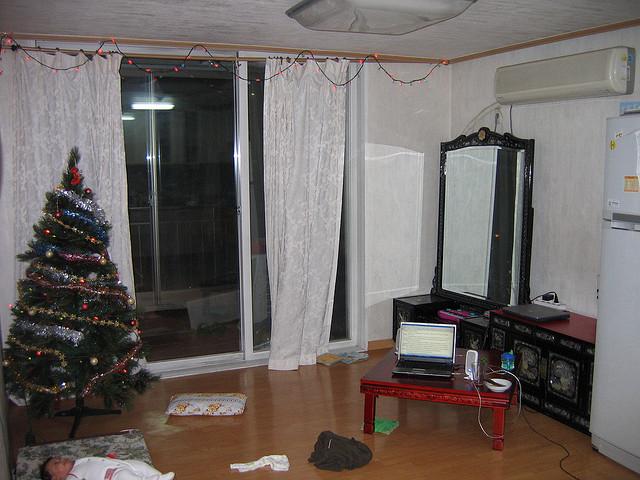Is the patio door open?
Concise answer only. No. Is this a good place to sleep when camping?
Keep it brief. No. Do you see a hammer?
Short answer required. No. Is the window open?
Write a very short answer. No. Is there flowers in the picture?
Give a very brief answer. No. Is this the patio?
Keep it brief. No. What piece of furniture is this?
Keep it brief. Table. Is there a candle in the image?
Write a very short answer. No. What room is this?
Be succinct. Living room. Is it night?
Concise answer only. Yes. Was there a party when this photo was taken?
Keep it brief. No. What holiday is the room decorated for?
Short answer required. Christmas. What object in the room can cool it off?
Quick response, please. Air conditioner. Is this clean?
Give a very brief answer. No. 